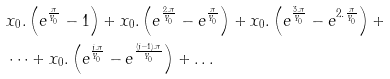Convert formula to latex. <formula><loc_0><loc_0><loc_500><loc_500>& x _ { 0 } . \left ( e ^ { \frac { \pi } { Y _ { 0 } } } - 1 \right ) + x _ { 0 } . \left ( e ^ { \frac { 2 . \pi } { Y _ { 0 } } } - e ^ { \frac { \pi } { Y _ { 0 } } } \right ) + x _ { 0 } . \left ( e ^ { \frac { 3 . \pi } { Y _ { 0 } } } - e ^ { 2 . \frac { \pi } { Y _ { 0 } } } \right ) + \\ & \dots + x _ { 0 } . \left ( e ^ { \frac { j . \pi } { Y _ { 0 } } } - e ^ { \frac { ( j - 1 ) . \pi } { Y _ { 0 } } } \right ) + \dots</formula> 